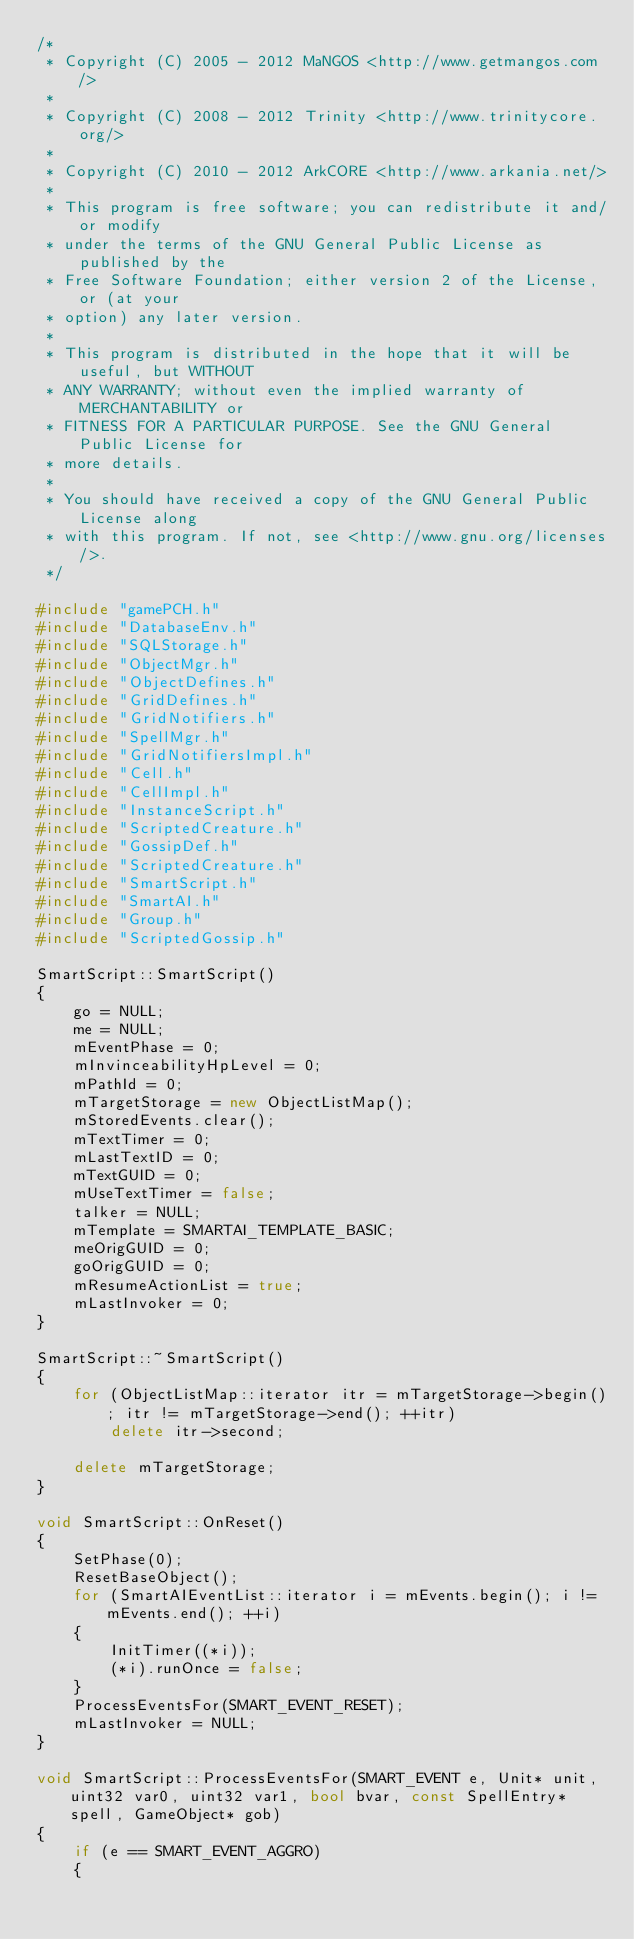Convert code to text. <code><loc_0><loc_0><loc_500><loc_500><_C++_>/*
 * Copyright (C) 2005 - 2012 MaNGOS <http://www.getmangos.com/>
 *
 * Copyright (C) 2008 - 2012 Trinity <http://www.trinitycore.org/>
 *
 * Copyright (C) 2010 - 2012 ArkCORE <http://www.arkania.net/>
 *
 * This program is free software; you can redistribute it and/or modify
 * under the terms of the GNU General Public License as published by the
 * Free Software Foundation; either version 2 of the License, or (at your
 * option) any later version.
 *
 * This program is distributed in the hope that it will be useful, but WITHOUT
 * ANY WARRANTY; without even the implied warranty of MERCHANTABILITY or
 * FITNESS FOR A PARTICULAR PURPOSE. See the GNU General Public License for
 * more details.
 *
 * You should have received a copy of the GNU General Public License along
 * with this program. If not, see <http://www.gnu.org/licenses/>.
 */

#include "gamePCH.h"
#include "DatabaseEnv.h"
#include "SQLStorage.h"
#include "ObjectMgr.h"
#include "ObjectDefines.h"
#include "GridDefines.h"
#include "GridNotifiers.h"
#include "SpellMgr.h"
#include "GridNotifiersImpl.h"
#include "Cell.h"
#include "CellImpl.h"
#include "InstanceScript.h"
#include "ScriptedCreature.h"
#include "GossipDef.h"
#include "ScriptedCreature.h"
#include "SmartScript.h"
#include "SmartAI.h"
#include "Group.h"
#include "ScriptedGossip.h"

SmartScript::SmartScript()
{
    go = NULL;
    me = NULL;
    mEventPhase = 0;
    mInvinceabilityHpLevel = 0;
    mPathId = 0;
    mTargetStorage = new ObjectListMap();
    mStoredEvents.clear();
    mTextTimer = 0;
    mLastTextID = 0;
    mTextGUID = 0;
    mUseTextTimer = false;
    talker = NULL;
    mTemplate = SMARTAI_TEMPLATE_BASIC;
    meOrigGUID = 0;
    goOrigGUID = 0;
    mResumeActionList = true;
    mLastInvoker = 0;
}

SmartScript::~SmartScript()
{
    for (ObjectListMap::iterator itr = mTargetStorage->begin(); itr != mTargetStorage->end(); ++itr)
        delete itr->second;

    delete mTargetStorage;
}

void SmartScript::OnReset()
{
    SetPhase(0);
    ResetBaseObject();
    for (SmartAIEventList::iterator i = mEvents.begin(); i != mEvents.end(); ++i)
    {
        InitTimer((*i));
        (*i).runOnce = false;
    }
    ProcessEventsFor(SMART_EVENT_RESET);
    mLastInvoker = NULL;
}

void SmartScript::ProcessEventsFor(SMART_EVENT e, Unit* unit, uint32 var0, uint32 var1, bool bvar, const SpellEntry* spell, GameObject* gob)
{
    if (e == SMART_EVENT_AGGRO)
    {</code> 